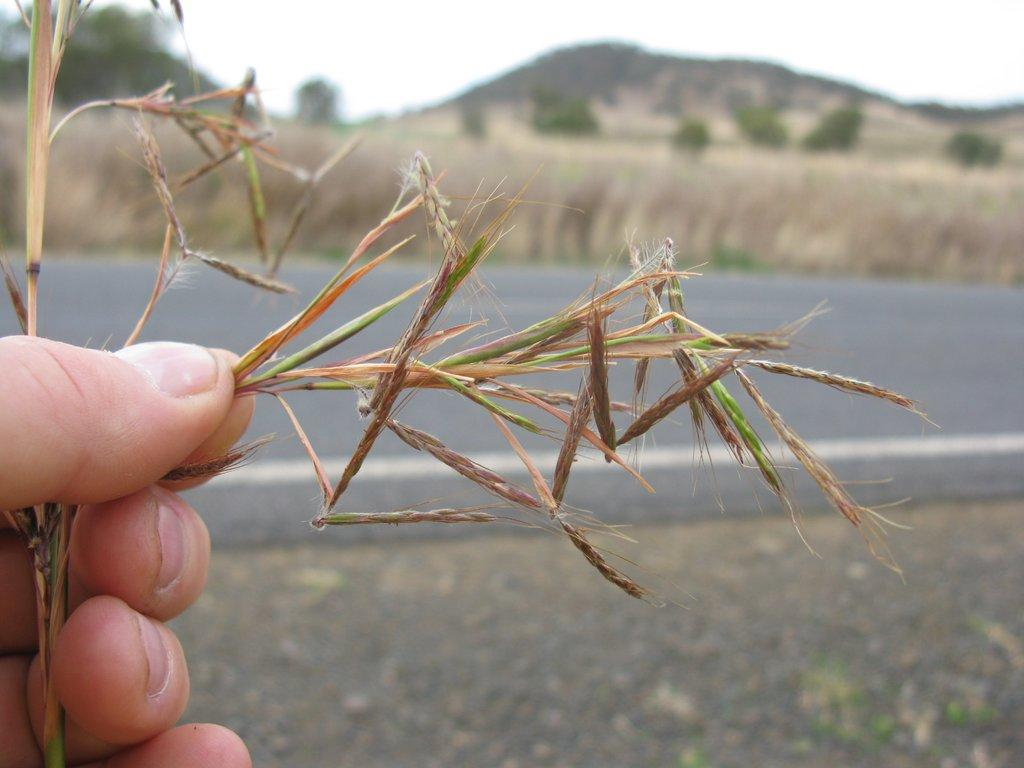What is being held by the hand in the image? The hand is holding a wheat plant in the image. What other natural elements can be seen in the image? There are trees visible at the top of the image. What is visible in the background of the image? The sky is visible at the top of the image. What type of wealth is being displayed in the image? There is no indication of wealth in the image; it features a hand holding a wheat plant and trees in the background. 